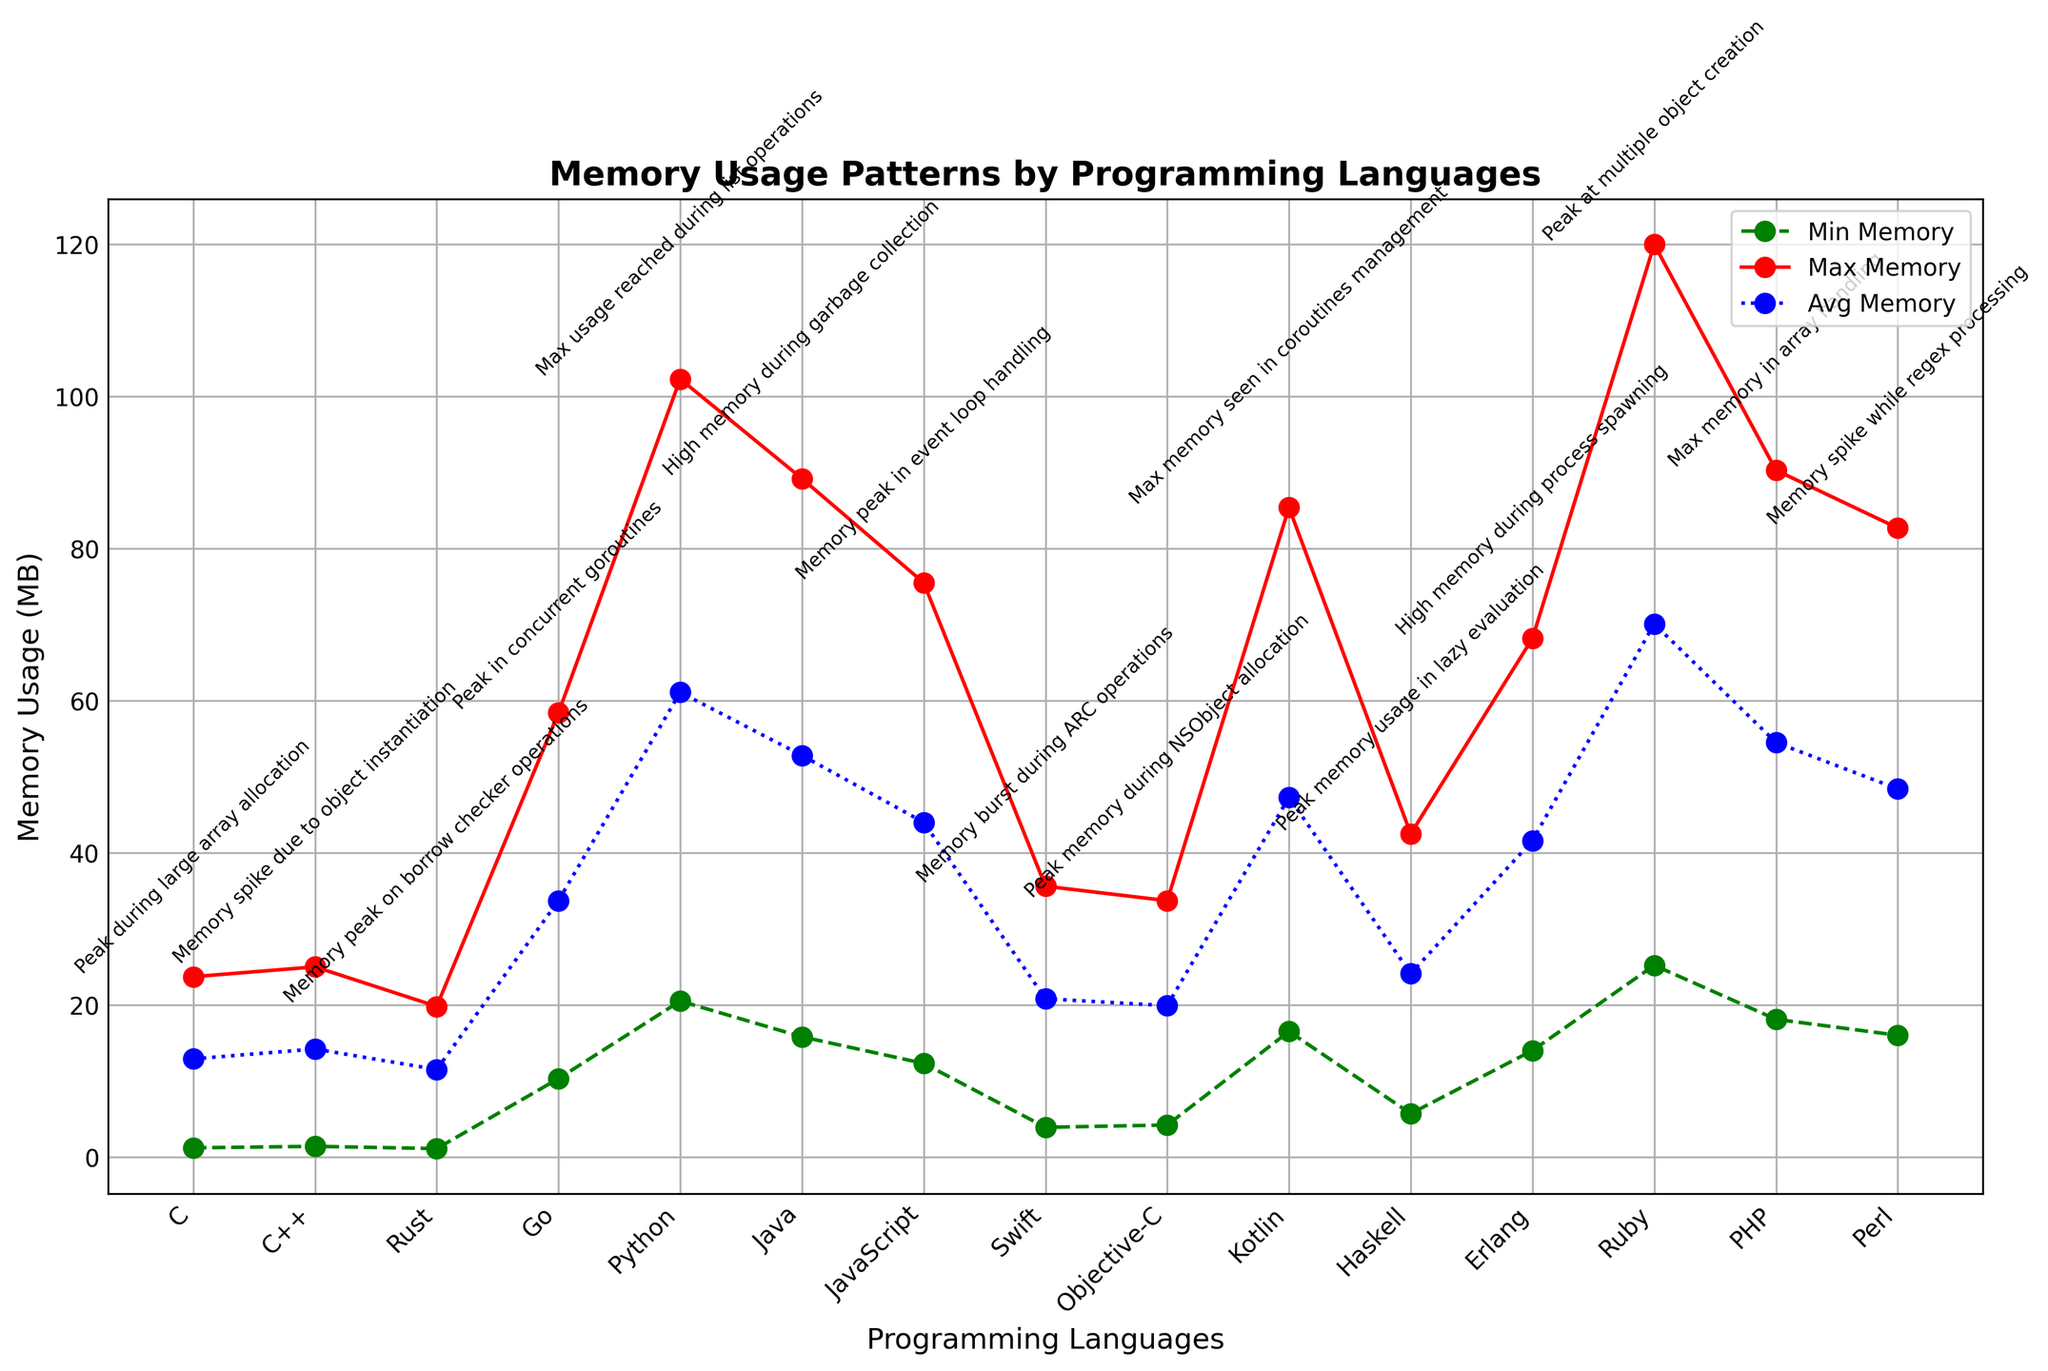Which language has the highest peak memory usage? In the figure, the highest peak memory usage is indicated by the highest point on the red line. The maximum value is 120.0 MB, which corresponds to Ruby.
Answer: Ruby What is the average memory usage difference between Python and Go? Calculate the average memory usage of Python (61.1 MB) and Go (33.7 MB). The difference is calculated as 61.1 - 33.7.
Answer: 27.4 MB Which language has the lowest minimum memory usage, and what is the value? The lowest minimum memory usage is indicated by the lowest point on the green line. The minimum value is 1.1 MB, corresponding to Rust.
Answer: Rust, 1.1 MB What annotation is given for JavaScript's peak memory usage? The annotation for JavaScript's peak memory usage is written next to the highest point on the red line for JavaScript. It states "Memory peak in event loop handling."
Answer: Memory peak in event loop handling Which language shows a higher maximum memory usage: Java or Kotlin? Compare the maximum memory usage for Java (89.2 MB) and Kotlin (85.4 MB). Java has a higher maximum value.
Answer: Java What is the total memory usage range (difference between the maximum and minimum values) for PHP? Calculate the difference between PHP's maximum memory usage (90.3 MB) and minimum memory usage (18.1 MB) to find the range. The range is 90.3 - 18.1.
Answer: 72.2 MB How much higher is Ruby's peak memory usage compared to C's peak memory usage? Calculate the difference between Ruby's maximum memory usage (120.0 MB) and C's maximum memory usage (23.7 MB). The difference is 120.0 - 23.7.
Answer: 96.3 MB What is the annotation for peak memory usage in Python? The annotation for Python’s peak memory usage can be found next to the highest point on the red line for Python. It states "Max usage reached during list operations."
Answer: Max usage reached during list operations Which languages have average memory usage above 50 MB? Looking at the blue line and corresponding labels, the languages with average memory usage above 50 MB are Python (61.1 MB), Java (52.8 MB), Ruby (70.1 MB), PHP (54.5 MB), Kotlin (47.3 MB), and Perl (48.4 MB). Out of these, only Python, Java, Ruby, and PHP have average memory usage above 50 MB.
Answer: Python, Java, Ruby, PHP What is the total average memory usage for Rust, Swift, and Haskell combined? Add the average memory usage values of Rust (11.5 MB), Swift (20.8 MB), and Haskell (24.1 MB). The total is 11.5 + 20.8 + 24.1.
Answer: 56.4 MB 